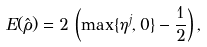<formula> <loc_0><loc_0><loc_500><loc_500>E ( \hat { \rho } ) = 2 \, \left ( \max \{ \eta ^ { j } , 0 \} - \frac { 1 } { 2 } \right ) ,</formula> 